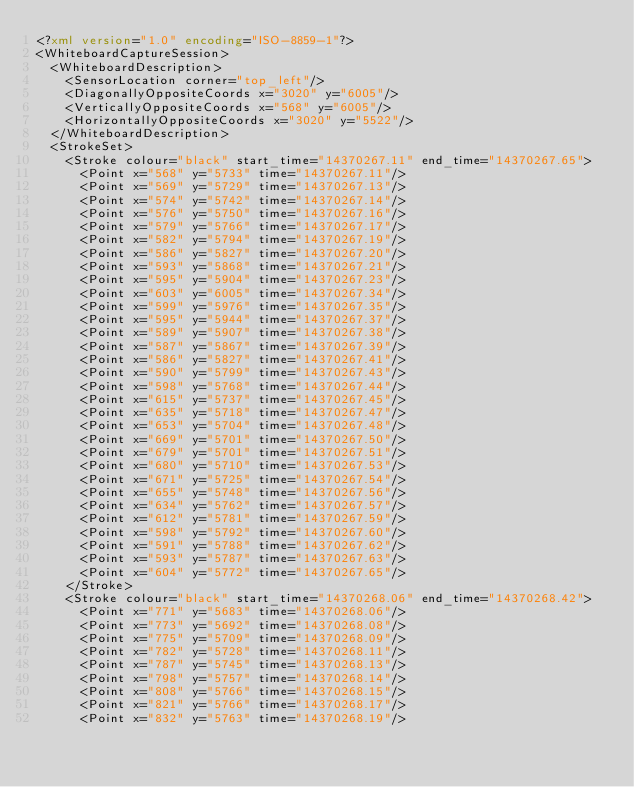Convert code to text. <code><loc_0><loc_0><loc_500><loc_500><_XML_><?xml version="1.0" encoding="ISO-8859-1"?>
<WhiteboardCaptureSession>
  <WhiteboardDescription>
    <SensorLocation corner="top_left"/>
    <DiagonallyOppositeCoords x="3020" y="6005"/>
    <VerticallyOppositeCoords x="568" y="6005"/>
    <HorizontallyOppositeCoords x="3020" y="5522"/>
  </WhiteboardDescription>
  <StrokeSet>
    <Stroke colour="black" start_time="14370267.11" end_time="14370267.65">
      <Point x="568" y="5733" time="14370267.11"/>
      <Point x="569" y="5729" time="14370267.13"/>
      <Point x="574" y="5742" time="14370267.14"/>
      <Point x="576" y="5750" time="14370267.16"/>
      <Point x="579" y="5766" time="14370267.17"/>
      <Point x="582" y="5794" time="14370267.19"/>
      <Point x="586" y="5827" time="14370267.20"/>
      <Point x="593" y="5868" time="14370267.21"/>
      <Point x="595" y="5904" time="14370267.23"/>
      <Point x="603" y="6005" time="14370267.34"/>
      <Point x="599" y="5976" time="14370267.35"/>
      <Point x="595" y="5944" time="14370267.37"/>
      <Point x="589" y="5907" time="14370267.38"/>
      <Point x="587" y="5867" time="14370267.39"/>
      <Point x="586" y="5827" time="14370267.41"/>
      <Point x="590" y="5799" time="14370267.43"/>
      <Point x="598" y="5768" time="14370267.44"/>
      <Point x="615" y="5737" time="14370267.45"/>
      <Point x="635" y="5718" time="14370267.47"/>
      <Point x="653" y="5704" time="14370267.48"/>
      <Point x="669" y="5701" time="14370267.50"/>
      <Point x="679" y="5701" time="14370267.51"/>
      <Point x="680" y="5710" time="14370267.53"/>
      <Point x="671" y="5725" time="14370267.54"/>
      <Point x="655" y="5748" time="14370267.56"/>
      <Point x="634" y="5762" time="14370267.57"/>
      <Point x="612" y="5781" time="14370267.59"/>
      <Point x="598" y="5792" time="14370267.60"/>
      <Point x="591" y="5788" time="14370267.62"/>
      <Point x="593" y="5787" time="14370267.63"/>
      <Point x="604" y="5772" time="14370267.65"/>
    </Stroke>
    <Stroke colour="black" start_time="14370268.06" end_time="14370268.42">
      <Point x="771" y="5683" time="14370268.06"/>
      <Point x="773" y="5692" time="14370268.08"/>
      <Point x="775" y="5709" time="14370268.09"/>
      <Point x="782" y="5728" time="14370268.11"/>
      <Point x="787" y="5745" time="14370268.13"/>
      <Point x="798" y="5757" time="14370268.14"/>
      <Point x="808" y="5766" time="14370268.15"/>
      <Point x="821" y="5766" time="14370268.17"/>
      <Point x="832" y="5763" time="14370268.19"/></code> 